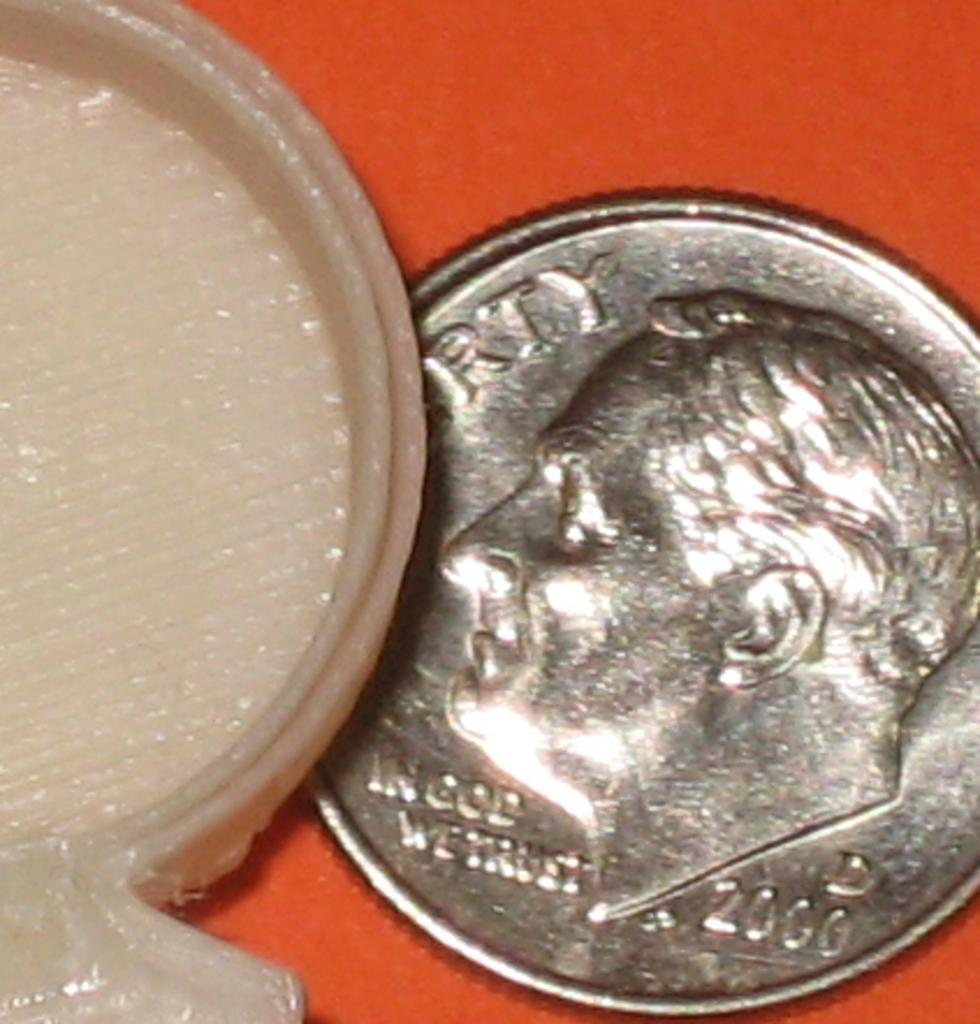<image>
Present a compact description of the photo's key features. A dime with the words "In God We Trust" and "D 2000" visible on it is set next to another object. 